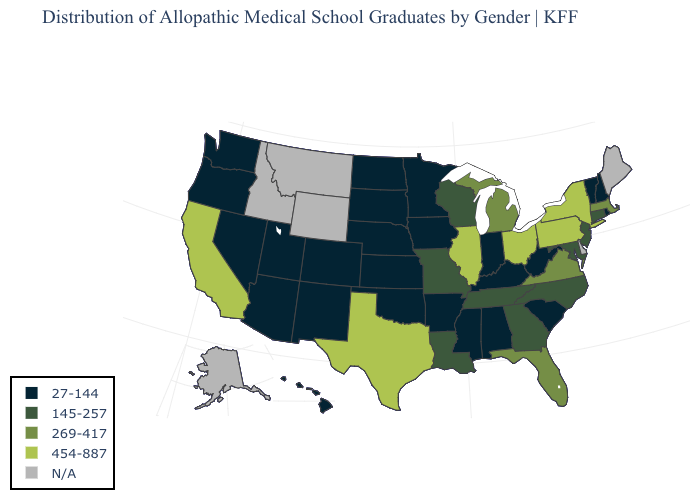What is the value of Arizona?
Answer briefly. 27-144. What is the value of Michigan?
Be succinct. 269-417. What is the highest value in states that border Montana?
Give a very brief answer. 27-144. Name the states that have a value in the range 27-144?
Be succinct. Alabama, Arizona, Arkansas, Colorado, Hawaii, Indiana, Iowa, Kansas, Kentucky, Minnesota, Mississippi, Nebraska, Nevada, New Hampshire, New Mexico, North Dakota, Oklahoma, Oregon, Rhode Island, South Carolina, South Dakota, Utah, Vermont, Washington, West Virginia. Does California have the lowest value in the West?
Keep it brief. No. Name the states that have a value in the range N/A?
Quick response, please. Alaska, Delaware, Idaho, Maine, Montana, Wyoming. What is the value of Florida?
Answer briefly. 269-417. What is the highest value in states that border West Virginia?
Short answer required. 454-887. How many symbols are there in the legend?
Give a very brief answer. 5. What is the lowest value in states that border Virginia?
Answer briefly. 27-144. What is the value of West Virginia?
Keep it brief. 27-144. Name the states that have a value in the range 269-417?
Short answer required. Florida, Massachusetts, Michigan, Virginia. Does the map have missing data?
Concise answer only. Yes. Does North Carolina have the highest value in the South?
Short answer required. No. 